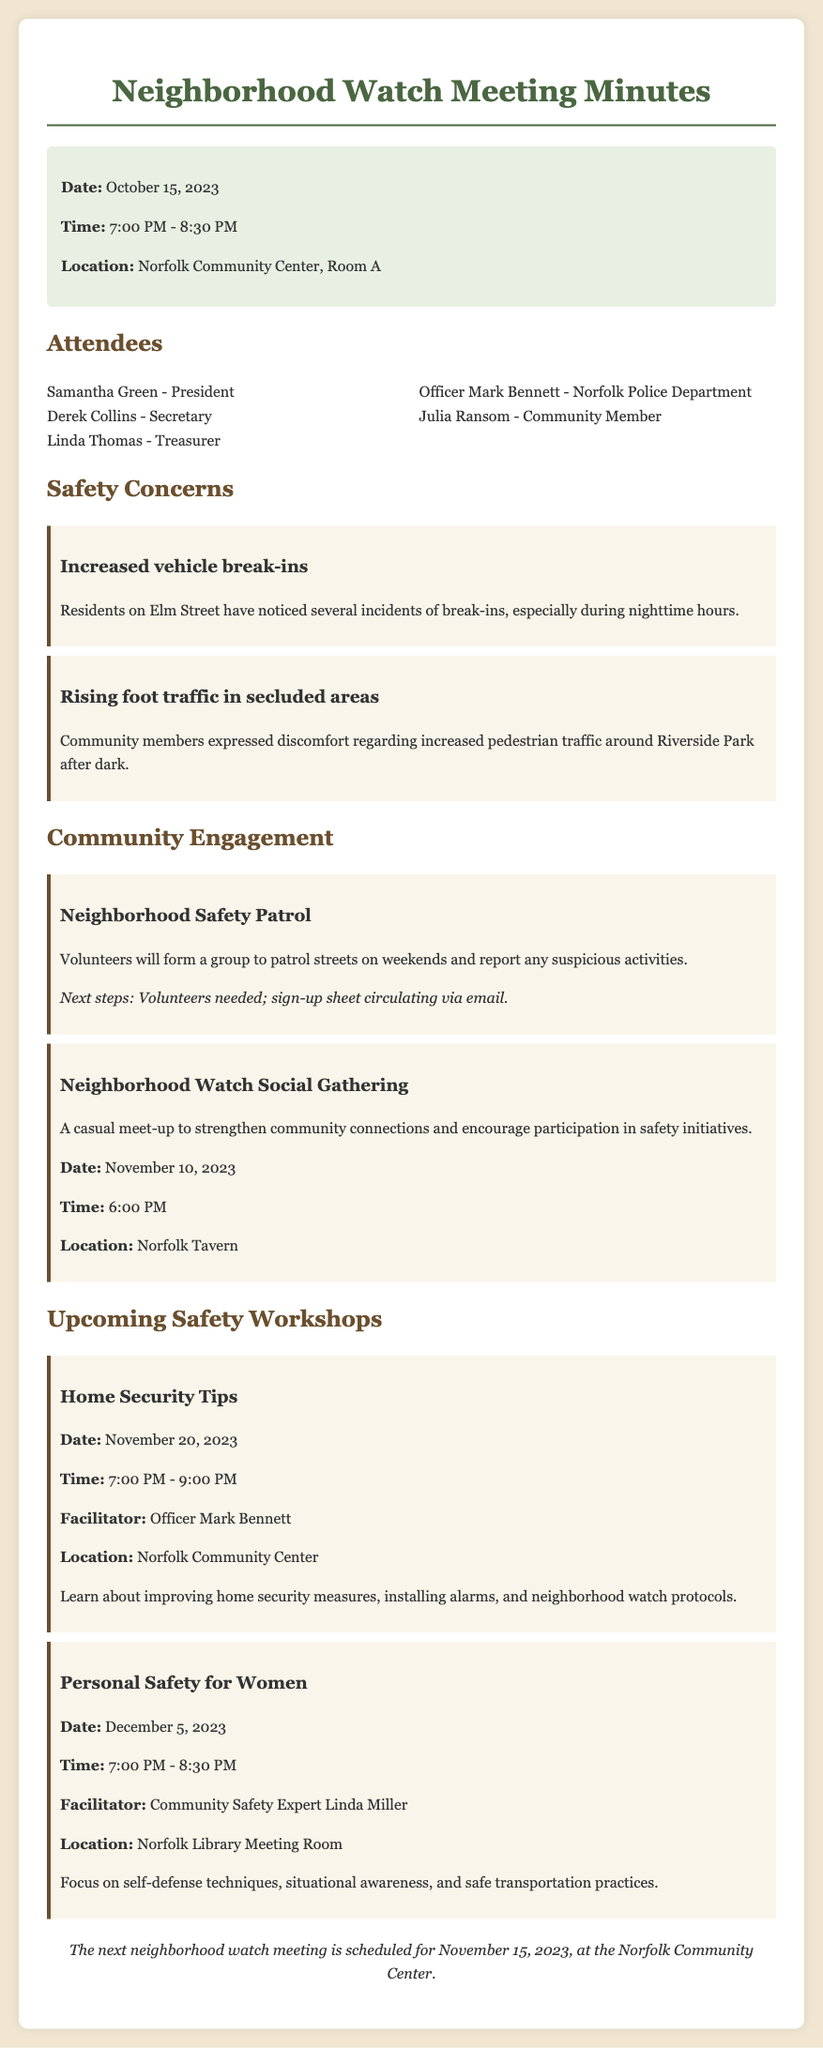what is the date of the next neighborhood watch meeting? The date of the next neighborhood watch meeting is mentioned in the document as November 15, 2023.
Answer: November 15, 2023 who is the facilitator for the Home Security Tips workshop? The facilitator for the Home Security Tips workshop is listed as Officer Mark Bennett in the document.
Answer: Officer Mark Bennett what are the two main safety concerns raised by residents? The document highlights increased vehicle break-ins and rising foot traffic in secluded areas as the main safety concerns.
Answer: Increased vehicle break-ins; Rising foot traffic in secluded areas when is the Neighborhood Watch Social Gathering scheduled? The Neighborhood Watch Social Gathering is scheduled for November 10, 2023, according to the meeting minutes.
Answer: November 10, 2023 what location is specified for the Personal Safety for Women workshop? The location specified for the Personal Safety for Women workshop is the Norfolk Library Meeting Room.
Answer: Norfolk Library Meeting Room how long will the Home Security Tips workshop last? The document indicates that the Home Security Tips workshop will last for two hours, from 7:00 PM to 9:00 PM.
Answer: 2 hours what is the purpose of the Neighborhood Safety Patrol initiative? The purpose of the Neighborhood Safety Patrol initiative is to patrol streets on weekends and report any suspicious activities, as mentioned in the community engagement section.
Answer: Patrol streets on weekends; report suspicious activities who presented at the meeting from the Norfolk Police Department? Officer Mark Bennett is the representative from the Norfolk Police Department mentioned in the attendees list.
Answer: Officer Mark Bennett 